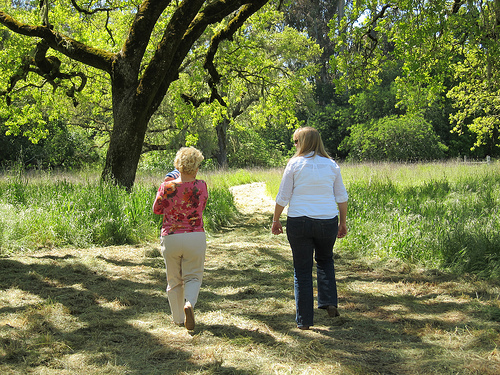<image>
Is the old lady to the left of the lady? Yes. From this viewpoint, the old lady is positioned to the left side relative to the lady. Is there a woman behind the plant? No. The woman is not behind the plant. From this viewpoint, the woman appears to be positioned elsewhere in the scene. Is the woman behind the tree? No. The woman is not behind the tree. From this viewpoint, the woman appears to be positioned elsewhere in the scene. 